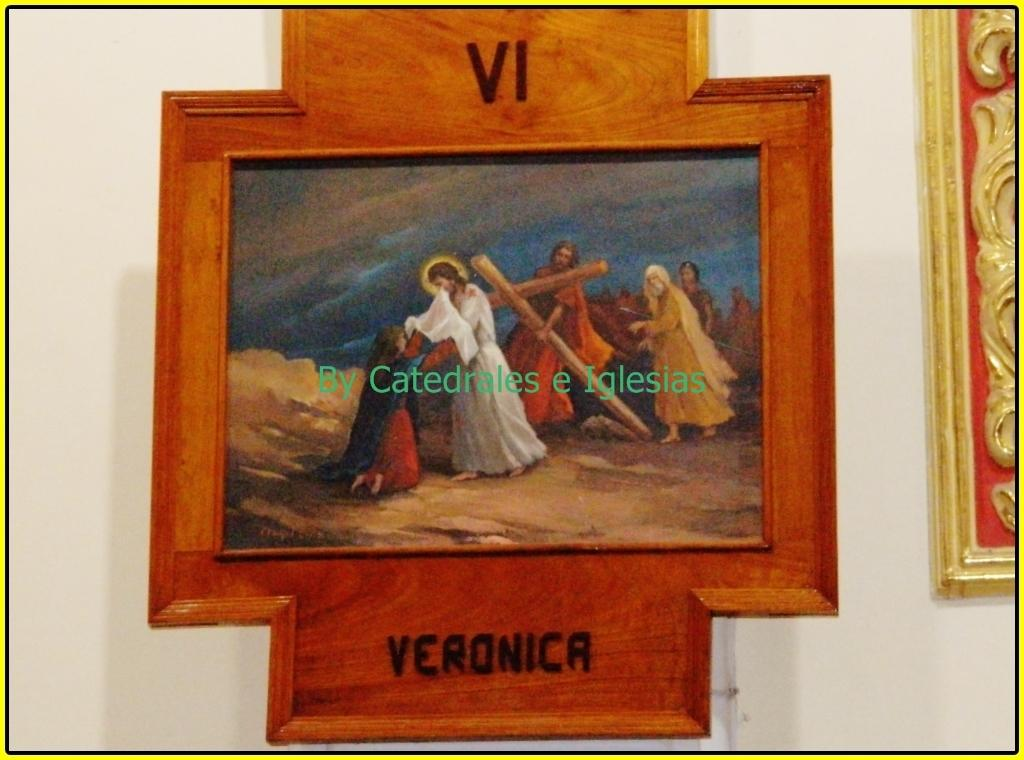What object can be seen in the image that typically holds a photograph? There is a photo frame in the image. Where is the photo frame located? The photo frame is placed on a wall. What can be seen in the photo inside the frame? The photo contains an image of people. What are the people in the photo doing? The people in the image are standing and holding a wooden cross. Can you tell me how many fish are swimming in the sea in the image? There is no sea or fish present in the image; it features a photo frame with a photo of people holding a wooden cross. 